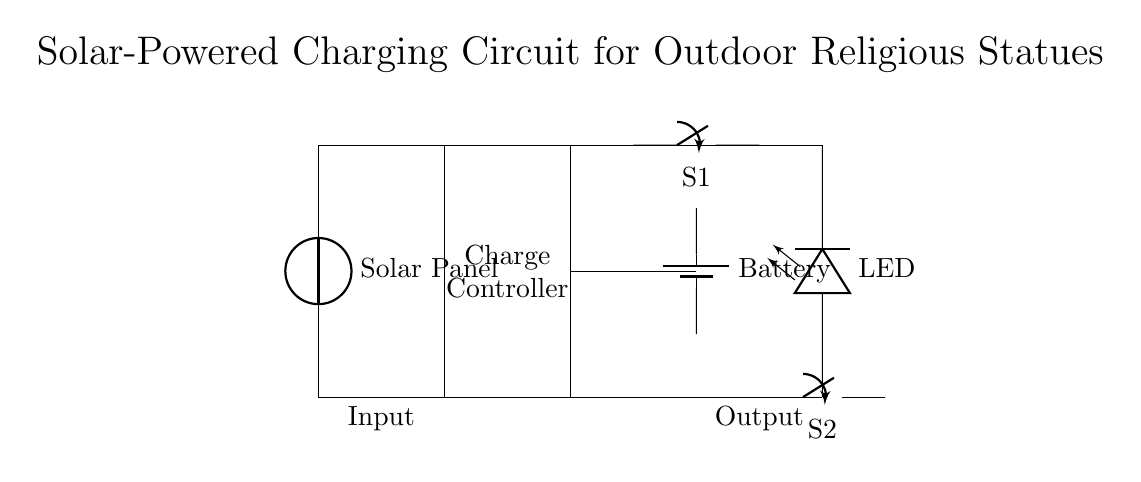What is the primary energy source for this circuit? The primary energy source is the solar panel, which converts sunlight into electrical energy.
Answer: Solar panel What is the purpose of the charge controller? The charge controller regulates the charging of the battery, ensuring it does not overcharge or over-discharge.
Answer: Regulates charging How many switches are present in the circuit? There are two switches in the circuit, labeled S1 and S2.
Answer: Two What component indicates whether the circuit is active? The LED light indicates whether the circuit is active, as it lights up when the circuit is energized.
Answer: LED What is the relationship between the solar panel and the battery? The solar panel charges the battery, providing it with power derived from sunlight.
Answer: Charges Which component is connected directly between the solar panel and the battery? The charge controller is connected directly between the solar panel and the battery to manage the power flow.
Answer: Charge controller 